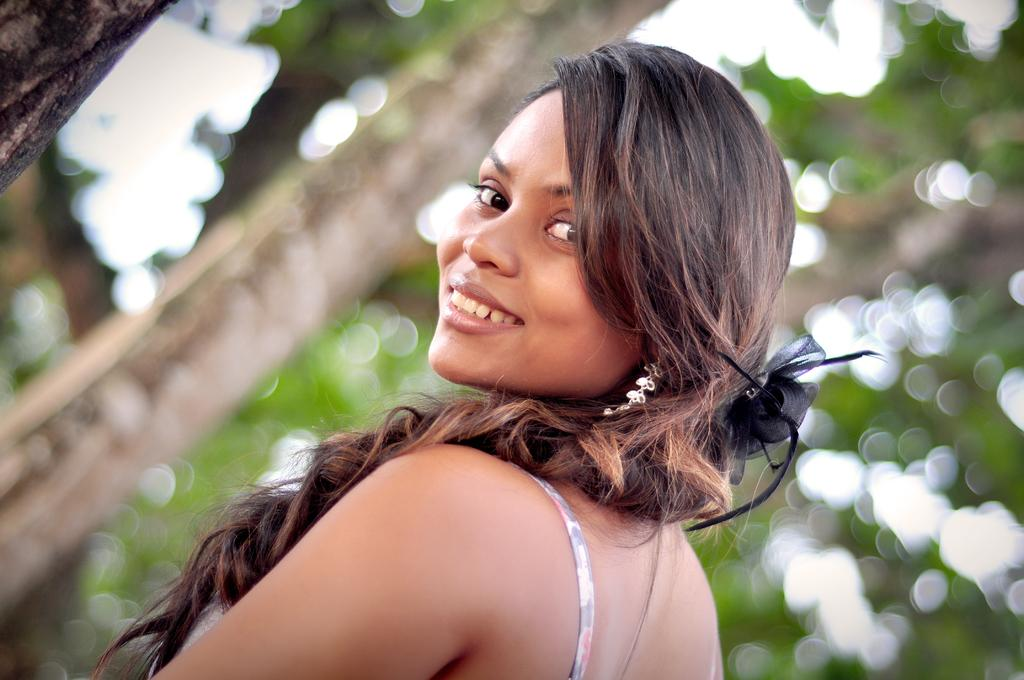What is the main subject of the image? There is a woman standing in the center of the image. What is the woman's facial expression? The woman is smiling. What can be seen in the background of the image? Trees are visible in the background of the image. What type of jar can be seen in the woman's hand in the image? There is no jar present in the image; the woman is not holding anything. How does the woman's anger affect the trees in the background? The woman is not displaying anger in the image, and there is no indication that her emotions have any effect on the trees. 